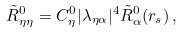Convert formula to latex. <formula><loc_0><loc_0><loc_500><loc_500>\tilde { R } _ { \eta \eta } ^ { 0 } = C ^ { 0 } _ { \eta } | \lambda _ { \eta \alpha } | ^ { 4 } \tilde { R } ^ { 0 } _ { \alpha } ( r _ { s } ) \, ,</formula> 